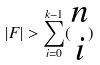Convert formula to latex. <formula><loc_0><loc_0><loc_500><loc_500>| F | > \sum _ { i = 0 } ^ { k - 1 } ( \begin{matrix} n \\ i \end{matrix} )</formula> 